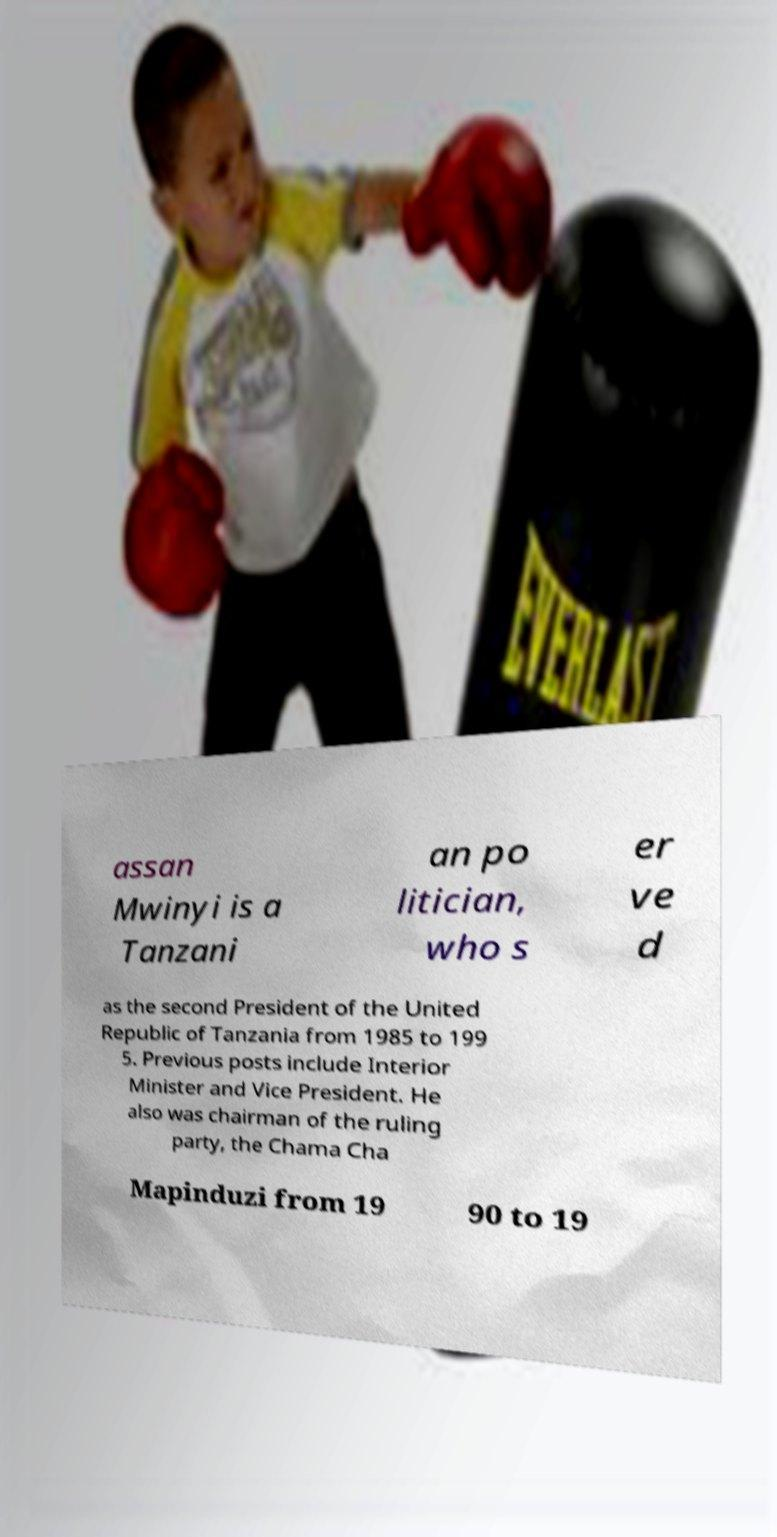Could you extract and type out the text from this image? assan Mwinyi is a Tanzani an po litician, who s er ve d as the second President of the United Republic of Tanzania from 1985 to 199 5. Previous posts include Interior Minister and Vice President. He also was chairman of the ruling party, the Chama Cha Mapinduzi from 19 90 to 19 